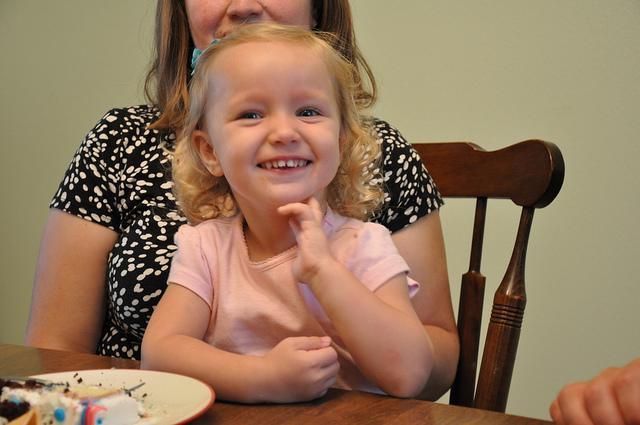How many people can you see?
Give a very brief answer. 3. How many dining tables can you see?
Give a very brief answer. 1. 